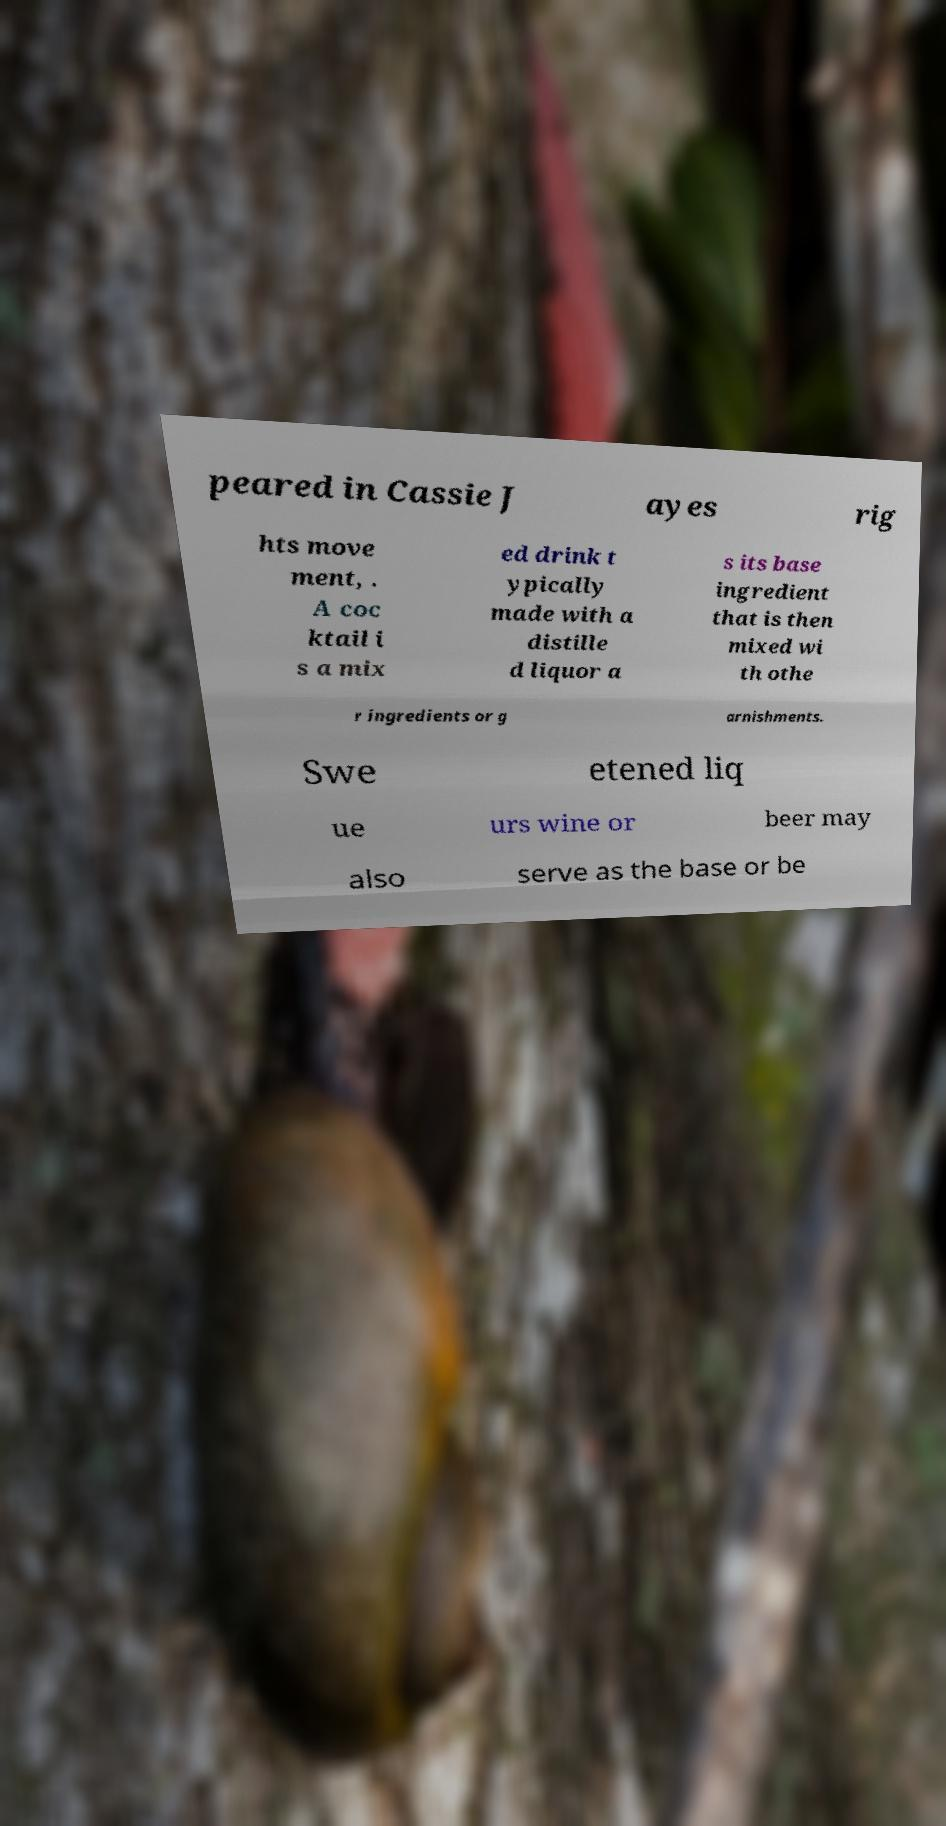What messages or text are displayed in this image? I need them in a readable, typed format. peared in Cassie J ayes rig hts move ment, . A coc ktail i s a mix ed drink t ypically made with a distille d liquor a s its base ingredient that is then mixed wi th othe r ingredients or g arnishments. Swe etened liq ue urs wine or beer may also serve as the base or be 